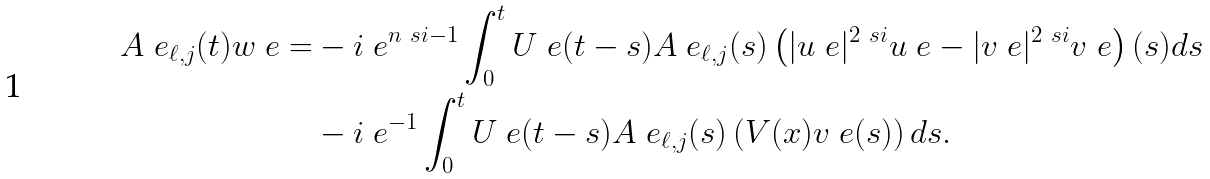Convert formula to latex. <formula><loc_0><loc_0><loc_500><loc_500>A ^ { \ } e _ { \ell , j } ( t ) w ^ { \ } e = & - i \ e ^ { n \ s i - 1 } \int _ { 0 } ^ { t } U ^ { \ } e ( t - s ) A ^ { \ } e _ { \ell , j } ( s ) \left ( | u ^ { \ } e | ^ { 2 \ s i } u ^ { \ } e - | v ^ { \ } e | ^ { 2 \ s i } v ^ { \ } e \right ) ( s ) d s \\ & - i \ e ^ { - 1 } \int _ { 0 } ^ { t } U ^ { \ } e ( t - s ) A ^ { \ } e _ { \ell , j } ( s ) \left ( V ( x ) v ^ { \ } e ( s ) \right ) d s .</formula> 